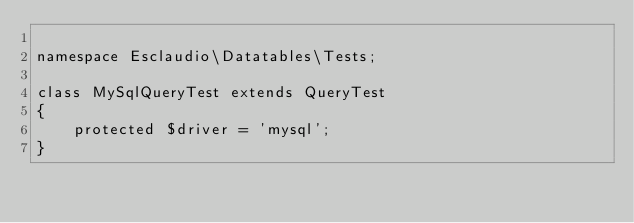<code> <loc_0><loc_0><loc_500><loc_500><_PHP_>
namespace Esclaudio\Datatables\Tests;

class MySqlQueryTest extends QueryTest
{
    protected $driver = 'mysql';
}
</code> 